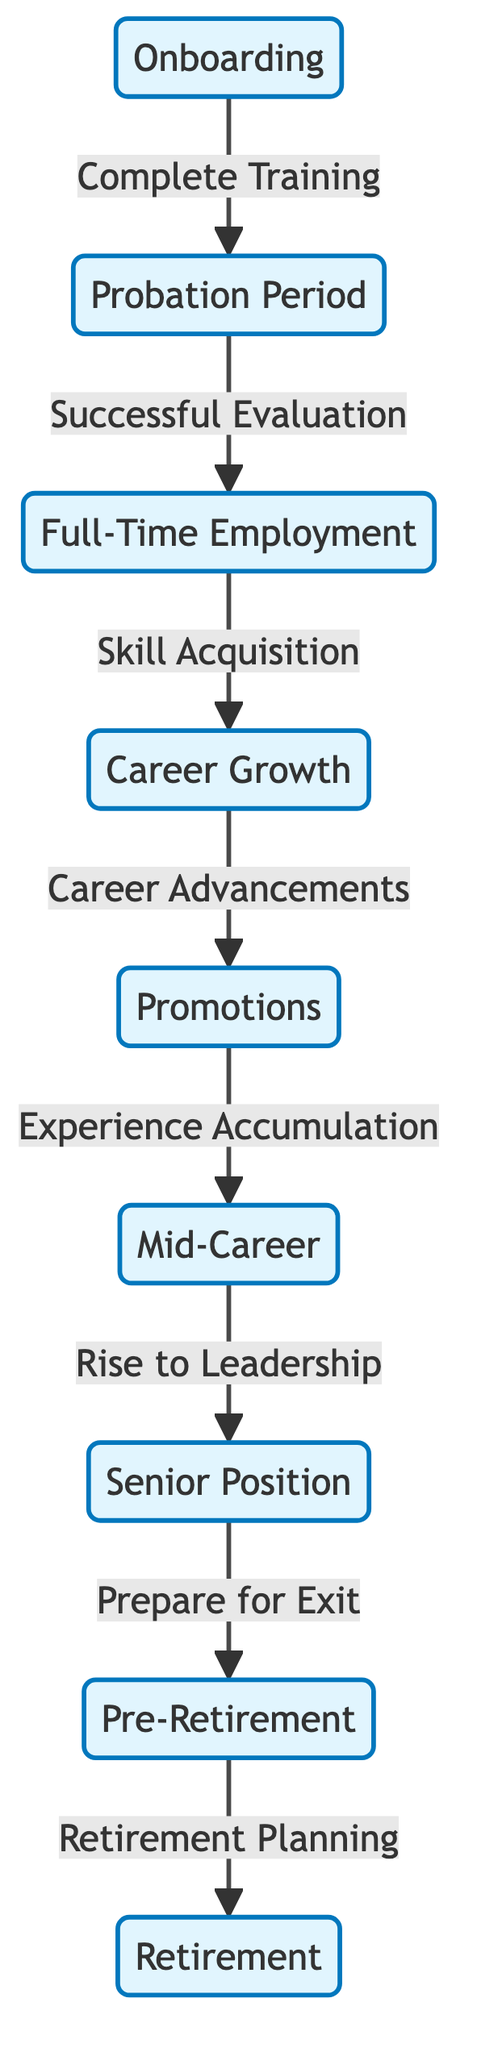What is the first phase of the employee lifecycle? The first phase is indicated by the leftmost node in the diagram, which is labeled "Onboarding."
Answer: Onboarding How many phases are there in the employee lifecycle? By counting all the nodes representing phases from onboarding to retirement, there are a total of nine phases.
Answer: Nine What is the transition that follows from "Senior Position"? The diagram shows that the transition following "Senior Position" leads to "Pre-Retirement."
Answer: Pre-Retirement What does the "Career Growth" phase lead to? The arrow emanating from the "Career Growth" phase points towards "Promotions," indicating it is the next phase.
Answer: Promotions What is the last phase in the employee lifecycle? The final node at the end of the diagram is labeled "Retirement," marking the conclusion of the lifecycle.
Answer: Retirement Which phase follows "Full-Time Employment"? According to the diagram, the next phase after "Full-Time Employment" is "Career Growth."
Answer: Career Growth What action is required to move from "Onboarding" to "Probation Period"? The transition from "Onboarding" to "Probation Period" requires the action "Complete Training," as indicated on the arrow connecting these two phases.
Answer: Complete Training How many transitions exist between "Mid-Career" and "Pre-Retirement"? There is a single direct transition connecting "Mid-Career" to "Pre-Retirement" as indicated by one arrow in the diagram.
Answer: One What is the main purpose of the "Pre-Retirement" phase? The diagram specifies that the "Pre-Retirement" phase involves "Retirement Planning," which is its central purpose.
Answer: Retirement Planning 